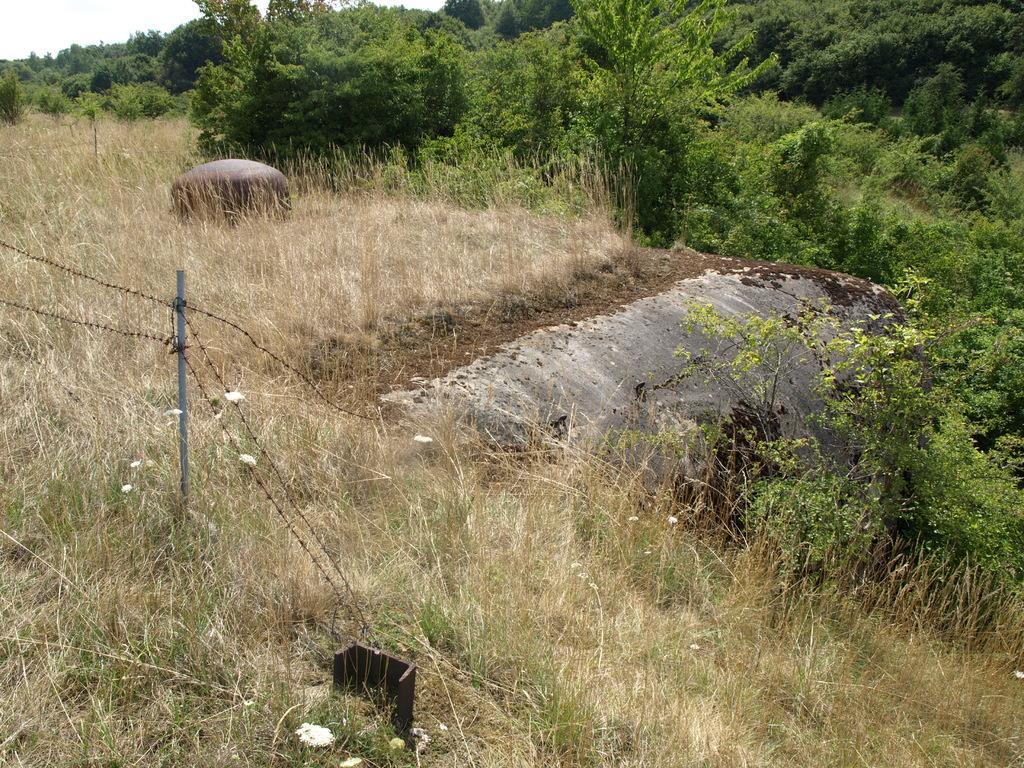Describe this image in one or two sentences. In this image there is a fence in the middle. At the bottom there is grass. On the right side there is a rock on which there is sand. In the middle there is a stone. In the background there are trees. 